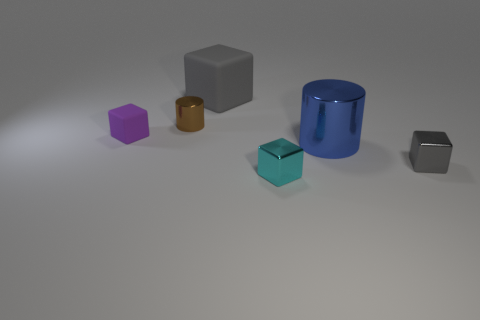Subtract all brown cubes. Subtract all green balls. How many cubes are left? 4 Add 2 brown metal cylinders. How many objects exist? 8 Subtract all cubes. How many objects are left? 2 Subtract all cyan matte things. Subtract all gray metal things. How many objects are left? 5 Add 6 tiny gray shiny blocks. How many tiny gray shiny blocks are left? 7 Add 2 tiny purple objects. How many tiny purple objects exist? 3 Subtract 2 gray cubes. How many objects are left? 4 